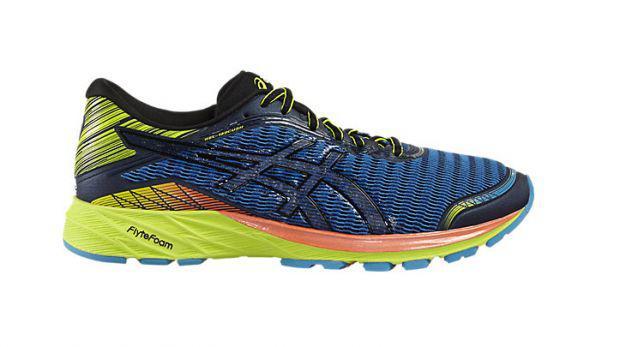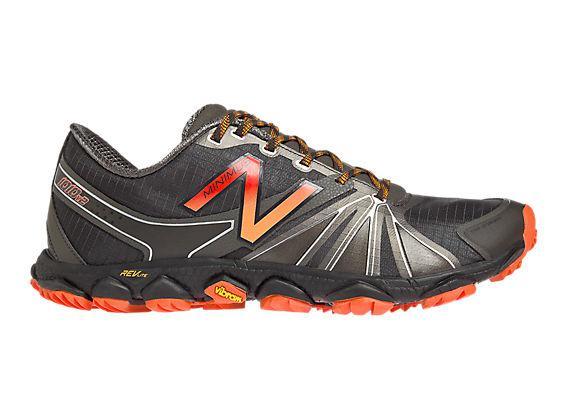The first image is the image on the left, the second image is the image on the right. Examine the images to the left and right. Is the description "There are atleast two shoes facing right" accurate? Answer yes or no. Yes. The first image is the image on the left, the second image is the image on the right. For the images displayed, is the sentence "Both shoes are pointing to the right." factually correct? Answer yes or no. Yes. 